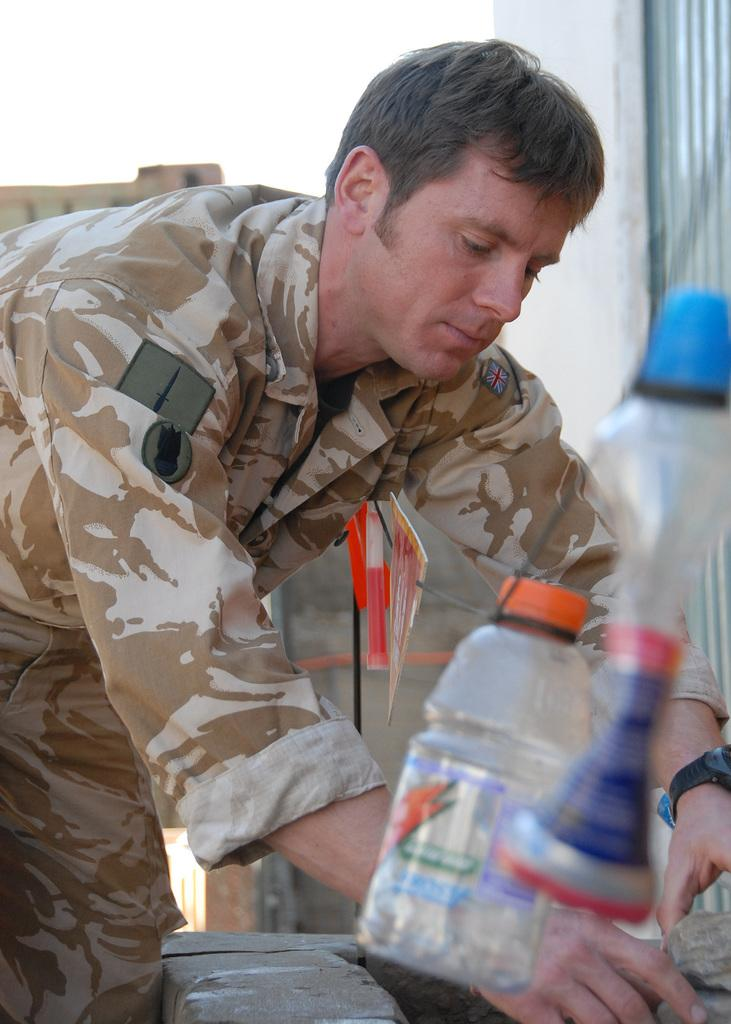Who or what is present in the image? There is a person in the image. What is the person doing in the image? The person is standing. What is the person wearing in the image? The person is wearing a uniform. What type of bear can be seen interacting with the person in the image? There is no bear present in the image; the person is the only subject. 